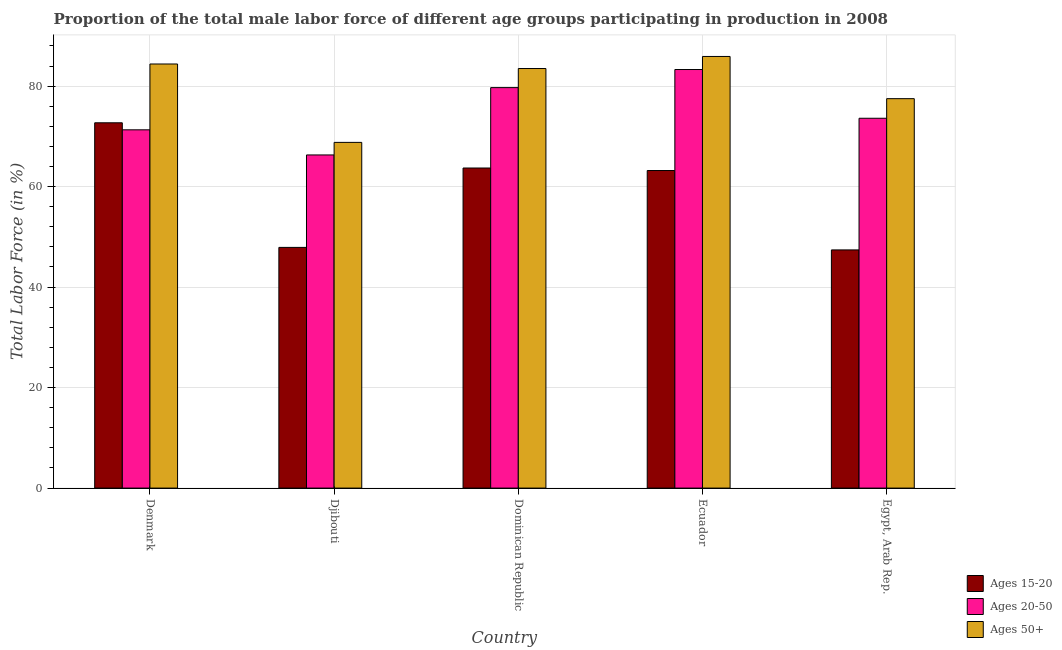How many different coloured bars are there?
Keep it short and to the point. 3. How many groups of bars are there?
Give a very brief answer. 5. Are the number of bars per tick equal to the number of legend labels?
Give a very brief answer. Yes. How many bars are there on the 3rd tick from the left?
Make the answer very short. 3. In how many cases, is the number of bars for a given country not equal to the number of legend labels?
Your answer should be very brief. 0. What is the percentage of male labor force above age 50 in Egypt, Arab Rep.?
Make the answer very short. 77.5. Across all countries, what is the maximum percentage of male labor force within the age group 15-20?
Your answer should be very brief. 72.7. Across all countries, what is the minimum percentage of male labor force within the age group 20-50?
Offer a terse response. 66.3. In which country was the percentage of male labor force within the age group 20-50 maximum?
Your response must be concise. Ecuador. In which country was the percentage of male labor force above age 50 minimum?
Offer a very short reply. Djibouti. What is the total percentage of male labor force above age 50 in the graph?
Your answer should be very brief. 400.1. What is the difference between the percentage of male labor force within the age group 20-50 in Djibouti and that in Dominican Republic?
Offer a very short reply. -13.4. What is the difference between the percentage of male labor force above age 50 in Ecuador and the percentage of male labor force within the age group 15-20 in Dominican Republic?
Your answer should be compact. 22.2. What is the average percentage of male labor force above age 50 per country?
Your answer should be very brief. 80.02. What is the difference between the percentage of male labor force within the age group 20-50 and percentage of male labor force within the age group 15-20 in Ecuador?
Keep it short and to the point. 20.1. What is the ratio of the percentage of male labor force above age 50 in Denmark to that in Dominican Republic?
Provide a succinct answer. 1.01. What is the difference between the highest and the second highest percentage of male labor force within the age group 20-50?
Make the answer very short. 3.6. What is the difference between the highest and the lowest percentage of male labor force above age 50?
Provide a succinct answer. 17.1. In how many countries, is the percentage of male labor force within the age group 20-50 greater than the average percentage of male labor force within the age group 20-50 taken over all countries?
Offer a terse response. 2. What does the 2nd bar from the left in Djibouti represents?
Give a very brief answer. Ages 20-50. What does the 2nd bar from the right in Djibouti represents?
Your answer should be compact. Ages 20-50. Is it the case that in every country, the sum of the percentage of male labor force within the age group 15-20 and percentage of male labor force within the age group 20-50 is greater than the percentage of male labor force above age 50?
Ensure brevity in your answer.  Yes. Does the graph contain grids?
Provide a succinct answer. Yes. How many legend labels are there?
Provide a succinct answer. 3. How are the legend labels stacked?
Offer a very short reply. Vertical. What is the title of the graph?
Keep it short and to the point. Proportion of the total male labor force of different age groups participating in production in 2008. Does "Ages 0-14" appear as one of the legend labels in the graph?
Give a very brief answer. No. What is the label or title of the Y-axis?
Your answer should be compact. Total Labor Force (in %). What is the Total Labor Force (in %) in Ages 15-20 in Denmark?
Give a very brief answer. 72.7. What is the Total Labor Force (in %) in Ages 20-50 in Denmark?
Your response must be concise. 71.3. What is the Total Labor Force (in %) in Ages 50+ in Denmark?
Ensure brevity in your answer.  84.4. What is the Total Labor Force (in %) of Ages 15-20 in Djibouti?
Offer a terse response. 47.9. What is the Total Labor Force (in %) in Ages 20-50 in Djibouti?
Provide a short and direct response. 66.3. What is the Total Labor Force (in %) in Ages 50+ in Djibouti?
Offer a very short reply. 68.8. What is the Total Labor Force (in %) in Ages 15-20 in Dominican Republic?
Your answer should be very brief. 63.7. What is the Total Labor Force (in %) in Ages 20-50 in Dominican Republic?
Keep it short and to the point. 79.7. What is the Total Labor Force (in %) in Ages 50+ in Dominican Republic?
Make the answer very short. 83.5. What is the Total Labor Force (in %) in Ages 15-20 in Ecuador?
Provide a succinct answer. 63.2. What is the Total Labor Force (in %) of Ages 20-50 in Ecuador?
Provide a succinct answer. 83.3. What is the Total Labor Force (in %) in Ages 50+ in Ecuador?
Offer a terse response. 85.9. What is the Total Labor Force (in %) of Ages 15-20 in Egypt, Arab Rep.?
Offer a terse response. 47.4. What is the Total Labor Force (in %) of Ages 20-50 in Egypt, Arab Rep.?
Offer a very short reply. 73.6. What is the Total Labor Force (in %) of Ages 50+ in Egypt, Arab Rep.?
Ensure brevity in your answer.  77.5. Across all countries, what is the maximum Total Labor Force (in %) in Ages 15-20?
Your answer should be compact. 72.7. Across all countries, what is the maximum Total Labor Force (in %) in Ages 20-50?
Offer a very short reply. 83.3. Across all countries, what is the maximum Total Labor Force (in %) in Ages 50+?
Provide a short and direct response. 85.9. Across all countries, what is the minimum Total Labor Force (in %) in Ages 15-20?
Provide a succinct answer. 47.4. Across all countries, what is the minimum Total Labor Force (in %) in Ages 20-50?
Offer a very short reply. 66.3. Across all countries, what is the minimum Total Labor Force (in %) of Ages 50+?
Offer a terse response. 68.8. What is the total Total Labor Force (in %) of Ages 15-20 in the graph?
Your response must be concise. 294.9. What is the total Total Labor Force (in %) in Ages 20-50 in the graph?
Provide a short and direct response. 374.2. What is the total Total Labor Force (in %) of Ages 50+ in the graph?
Provide a short and direct response. 400.1. What is the difference between the Total Labor Force (in %) in Ages 15-20 in Denmark and that in Djibouti?
Your response must be concise. 24.8. What is the difference between the Total Labor Force (in %) of Ages 20-50 in Denmark and that in Djibouti?
Keep it short and to the point. 5. What is the difference between the Total Labor Force (in %) in Ages 20-50 in Denmark and that in Dominican Republic?
Ensure brevity in your answer.  -8.4. What is the difference between the Total Labor Force (in %) in Ages 50+ in Denmark and that in Dominican Republic?
Ensure brevity in your answer.  0.9. What is the difference between the Total Labor Force (in %) in Ages 15-20 in Denmark and that in Egypt, Arab Rep.?
Provide a short and direct response. 25.3. What is the difference between the Total Labor Force (in %) of Ages 15-20 in Djibouti and that in Dominican Republic?
Provide a succinct answer. -15.8. What is the difference between the Total Labor Force (in %) in Ages 20-50 in Djibouti and that in Dominican Republic?
Your answer should be very brief. -13.4. What is the difference between the Total Labor Force (in %) in Ages 50+ in Djibouti and that in Dominican Republic?
Make the answer very short. -14.7. What is the difference between the Total Labor Force (in %) in Ages 15-20 in Djibouti and that in Ecuador?
Offer a terse response. -15.3. What is the difference between the Total Labor Force (in %) of Ages 50+ in Djibouti and that in Ecuador?
Provide a succinct answer. -17.1. What is the difference between the Total Labor Force (in %) in Ages 15-20 in Djibouti and that in Egypt, Arab Rep.?
Provide a succinct answer. 0.5. What is the difference between the Total Labor Force (in %) in Ages 20-50 in Djibouti and that in Egypt, Arab Rep.?
Ensure brevity in your answer.  -7.3. What is the difference between the Total Labor Force (in %) in Ages 20-50 in Dominican Republic and that in Ecuador?
Offer a very short reply. -3.6. What is the difference between the Total Labor Force (in %) of Ages 50+ in Dominican Republic and that in Ecuador?
Give a very brief answer. -2.4. What is the difference between the Total Labor Force (in %) of Ages 20-50 in Ecuador and that in Egypt, Arab Rep.?
Provide a short and direct response. 9.7. What is the difference between the Total Labor Force (in %) in Ages 15-20 in Denmark and the Total Labor Force (in %) in Ages 20-50 in Djibouti?
Provide a succinct answer. 6.4. What is the difference between the Total Labor Force (in %) in Ages 15-20 in Denmark and the Total Labor Force (in %) in Ages 50+ in Djibouti?
Offer a terse response. 3.9. What is the difference between the Total Labor Force (in %) in Ages 20-50 in Denmark and the Total Labor Force (in %) in Ages 50+ in Djibouti?
Your answer should be very brief. 2.5. What is the difference between the Total Labor Force (in %) of Ages 15-20 in Denmark and the Total Labor Force (in %) of Ages 50+ in Dominican Republic?
Offer a terse response. -10.8. What is the difference between the Total Labor Force (in %) in Ages 20-50 in Denmark and the Total Labor Force (in %) in Ages 50+ in Dominican Republic?
Your answer should be compact. -12.2. What is the difference between the Total Labor Force (in %) of Ages 15-20 in Denmark and the Total Labor Force (in %) of Ages 20-50 in Ecuador?
Ensure brevity in your answer.  -10.6. What is the difference between the Total Labor Force (in %) in Ages 15-20 in Denmark and the Total Labor Force (in %) in Ages 50+ in Ecuador?
Give a very brief answer. -13.2. What is the difference between the Total Labor Force (in %) in Ages 20-50 in Denmark and the Total Labor Force (in %) in Ages 50+ in Ecuador?
Your response must be concise. -14.6. What is the difference between the Total Labor Force (in %) in Ages 15-20 in Denmark and the Total Labor Force (in %) in Ages 20-50 in Egypt, Arab Rep.?
Your response must be concise. -0.9. What is the difference between the Total Labor Force (in %) in Ages 15-20 in Denmark and the Total Labor Force (in %) in Ages 50+ in Egypt, Arab Rep.?
Provide a short and direct response. -4.8. What is the difference between the Total Labor Force (in %) of Ages 15-20 in Djibouti and the Total Labor Force (in %) of Ages 20-50 in Dominican Republic?
Offer a very short reply. -31.8. What is the difference between the Total Labor Force (in %) of Ages 15-20 in Djibouti and the Total Labor Force (in %) of Ages 50+ in Dominican Republic?
Provide a succinct answer. -35.6. What is the difference between the Total Labor Force (in %) in Ages 20-50 in Djibouti and the Total Labor Force (in %) in Ages 50+ in Dominican Republic?
Make the answer very short. -17.2. What is the difference between the Total Labor Force (in %) in Ages 15-20 in Djibouti and the Total Labor Force (in %) in Ages 20-50 in Ecuador?
Provide a succinct answer. -35.4. What is the difference between the Total Labor Force (in %) in Ages 15-20 in Djibouti and the Total Labor Force (in %) in Ages 50+ in Ecuador?
Your response must be concise. -38. What is the difference between the Total Labor Force (in %) in Ages 20-50 in Djibouti and the Total Labor Force (in %) in Ages 50+ in Ecuador?
Offer a very short reply. -19.6. What is the difference between the Total Labor Force (in %) in Ages 15-20 in Djibouti and the Total Labor Force (in %) in Ages 20-50 in Egypt, Arab Rep.?
Your answer should be very brief. -25.7. What is the difference between the Total Labor Force (in %) in Ages 15-20 in Djibouti and the Total Labor Force (in %) in Ages 50+ in Egypt, Arab Rep.?
Provide a short and direct response. -29.6. What is the difference between the Total Labor Force (in %) in Ages 15-20 in Dominican Republic and the Total Labor Force (in %) in Ages 20-50 in Ecuador?
Offer a very short reply. -19.6. What is the difference between the Total Labor Force (in %) of Ages 15-20 in Dominican Republic and the Total Labor Force (in %) of Ages 50+ in Ecuador?
Ensure brevity in your answer.  -22.2. What is the difference between the Total Labor Force (in %) in Ages 15-20 in Dominican Republic and the Total Labor Force (in %) in Ages 20-50 in Egypt, Arab Rep.?
Your answer should be compact. -9.9. What is the difference between the Total Labor Force (in %) of Ages 15-20 in Dominican Republic and the Total Labor Force (in %) of Ages 50+ in Egypt, Arab Rep.?
Keep it short and to the point. -13.8. What is the difference between the Total Labor Force (in %) of Ages 20-50 in Dominican Republic and the Total Labor Force (in %) of Ages 50+ in Egypt, Arab Rep.?
Provide a succinct answer. 2.2. What is the difference between the Total Labor Force (in %) of Ages 15-20 in Ecuador and the Total Labor Force (in %) of Ages 50+ in Egypt, Arab Rep.?
Offer a terse response. -14.3. What is the difference between the Total Labor Force (in %) of Ages 20-50 in Ecuador and the Total Labor Force (in %) of Ages 50+ in Egypt, Arab Rep.?
Provide a short and direct response. 5.8. What is the average Total Labor Force (in %) of Ages 15-20 per country?
Keep it short and to the point. 58.98. What is the average Total Labor Force (in %) in Ages 20-50 per country?
Keep it short and to the point. 74.84. What is the average Total Labor Force (in %) in Ages 50+ per country?
Your answer should be very brief. 80.02. What is the difference between the Total Labor Force (in %) of Ages 15-20 and Total Labor Force (in %) of Ages 20-50 in Djibouti?
Keep it short and to the point. -18.4. What is the difference between the Total Labor Force (in %) in Ages 15-20 and Total Labor Force (in %) in Ages 50+ in Djibouti?
Offer a very short reply. -20.9. What is the difference between the Total Labor Force (in %) in Ages 15-20 and Total Labor Force (in %) in Ages 20-50 in Dominican Republic?
Offer a very short reply. -16. What is the difference between the Total Labor Force (in %) of Ages 15-20 and Total Labor Force (in %) of Ages 50+ in Dominican Republic?
Offer a very short reply. -19.8. What is the difference between the Total Labor Force (in %) in Ages 15-20 and Total Labor Force (in %) in Ages 20-50 in Ecuador?
Provide a succinct answer. -20.1. What is the difference between the Total Labor Force (in %) in Ages 15-20 and Total Labor Force (in %) in Ages 50+ in Ecuador?
Make the answer very short. -22.7. What is the difference between the Total Labor Force (in %) of Ages 20-50 and Total Labor Force (in %) of Ages 50+ in Ecuador?
Offer a very short reply. -2.6. What is the difference between the Total Labor Force (in %) in Ages 15-20 and Total Labor Force (in %) in Ages 20-50 in Egypt, Arab Rep.?
Offer a very short reply. -26.2. What is the difference between the Total Labor Force (in %) of Ages 15-20 and Total Labor Force (in %) of Ages 50+ in Egypt, Arab Rep.?
Your response must be concise. -30.1. What is the ratio of the Total Labor Force (in %) in Ages 15-20 in Denmark to that in Djibouti?
Make the answer very short. 1.52. What is the ratio of the Total Labor Force (in %) of Ages 20-50 in Denmark to that in Djibouti?
Make the answer very short. 1.08. What is the ratio of the Total Labor Force (in %) of Ages 50+ in Denmark to that in Djibouti?
Your answer should be very brief. 1.23. What is the ratio of the Total Labor Force (in %) in Ages 15-20 in Denmark to that in Dominican Republic?
Offer a very short reply. 1.14. What is the ratio of the Total Labor Force (in %) of Ages 20-50 in Denmark to that in Dominican Republic?
Provide a succinct answer. 0.89. What is the ratio of the Total Labor Force (in %) in Ages 50+ in Denmark to that in Dominican Republic?
Your response must be concise. 1.01. What is the ratio of the Total Labor Force (in %) of Ages 15-20 in Denmark to that in Ecuador?
Offer a very short reply. 1.15. What is the ratio of the Total Labor Force (in %) of Ages 20-50 in Denmark to that in Ecuador?
Give a very brief answer. 0.86. What is the ratio of the Total Labor Force (in %) in Ages 50+ in Denmark to that in Ecuador?
Ensure brevity in your answer.  0.98. What is the ratio of the Total Labor Force (in %) in Ages 15-20 in Denmark to that in Egypt, Arab Rep.?
Make the answer very short. 1.53. What is the ratio of the Total Labor Force (in %) in Ages 20-50 in Denmark to that in Egypt, Arab Rep.?
Your answer should be compact. 0.97. What is the ratio of the Total Labor Force (in %) of Ages 50+ in Denmark to that in Egypt, Arab Rep.?
Offer a terse response. 1.09. What is the ratio of the Total Labor Force (in %) of Ages 15-20 in Djibouti to that in Dominican Republic?
Ensure brevity in your answer.  0.75. What is the ratio of the Total Labor Force (in %) in Ages 20-50 in Djibouti to that in Dominican Republic?
Keep it short and to the point. 0.83. What is the ratio of the Total Labor Force (in %) of Ages 50+ in Djibouti to that in Dominican Republic?
Keep it short and to the point. 0.82. What is the ratio of the Total Labor Force (in %) of Ages 15-20 in Djibouti to that in Ecuador?
Provide a short and direct response. 0.76. What is the ratio of the Total Labor Force (in %) of Ages 20-50 in Djibouti to that in Ecuador?
Your response must be concise. 0.8. What is the ratio of the Total Labor Force (in %) of Ages 50+ in Djibouti to that in Ecuador?
Provide a short and direct response. 0.8. What is the ratio of the Total Labor Force (in %) in Ages 15-20 in Djibouti to that in Egypt, Arab Rep.?
Ensure brevity in your answer.  1.01. What is the ratio of the Total Labor Force (in %) of Ages 20-50 in Djibouti to that in Egypt, Arab Rep.?
Offer a very short reply. 0.9. What is the ratio of the Total Labor Force (in %) of Ages 50+ in Djibouti to that in Egypt, Arab Rep.?
Give a very brief answer. 0.89. What is the ratio of the Total Labor Force (in %) of Ages 15-20 in Dominican Republic to that in Ecuador?
Offer a very short reply. 1.01. What is the ratio of the Total Labor Force (in %) in Ages 20-50 in Dominican Republic to that in Ecuador?
Your answer should be compact. 0.96. What is the ratio of the Total Labor Force (in %) in Ages 50+ in Dominican Republic to that in Ecuador?
Provide a succinct answer. 0.97. What is the ratio of the Total Labor Force (in %) of Ages 15-20 in Dominican Republic to that in Egypt, Arab Rep.?
Offer a terse response. 1.34. What is the ratio of the Total Labor Force (in %) in Ages 20-50 in Dominican Republic to that in Egypt, Arab Rep.?
Your answer should be compact. 1.08. What is the ratio of the Total Labor Force (in %) in Ages 50+ in Dominican Republic to that in Egypt, Arab Rep.?
Ensure brevity in your answer.  1.08. What is the ratio of the Total Labor Force (in %) of Ages 15-20 in Ecuador to that in Egypt, Arab Rep.?
Your answer should be compact. 1.33. What is the ratio of the Total Labor Force (in %) in Ages 20-50 in Ecuador to that in Egypt, Arab Rep.?
Provide a short and direct response. 1.13. What is the ratio of the Total Labor Force (in %) in Ages 50+ in Ecuador to that in Egypt, Arab Rep.?
Provide a succinct answer. 1.11. What is the difference between the highest and the second highest Total Labor Force (in %) in Ages 15-20?
Provide a succinct answer. 9. What is the difference between the highest and the second highest Total Labor Force (in %) in Ages 50+?
Keep it short and to the point. 1.5. What is the difference between the highest and the lowest Total Labor Force (in %) of Ages 15-20?
Provide a succinct answer. 25.3. What is the difference between the highest and the lowest Total Labor Force (in %) of Ages 20-50?
Provide a succinct answer. 17. What is the difference between the highest and the lowest Total Labor Force (in %) in Ages 50+?
Provide a short and direct response. 17.1. 